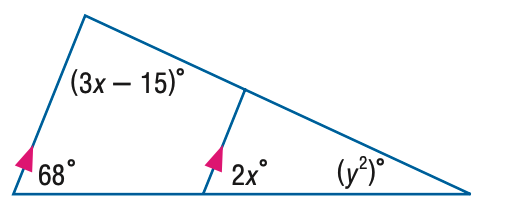Answer the mathemtical geometry problem and directly provide the correct option letter.
Question: Find x in the figure.
Choices: A: 27.7 B: 34 C: 41.3 D: 68 B 